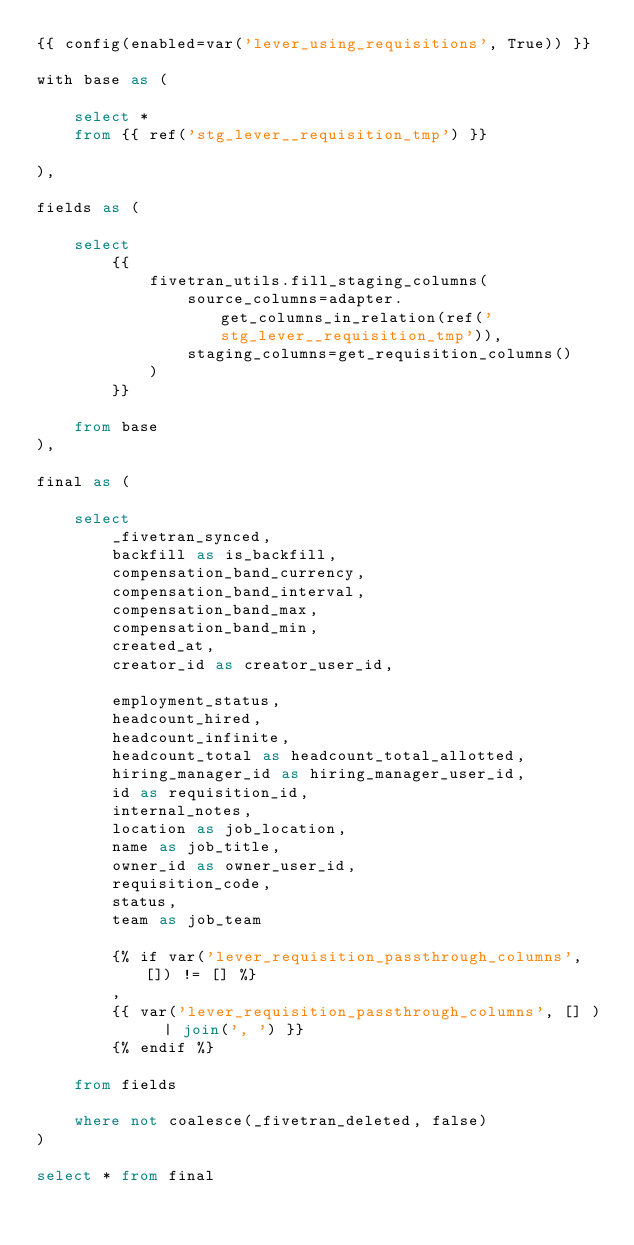<code> <loc_0><loc_0><loc_500><loc_500><_SQL_>{{ config(enabled=var('lever_using_requisitions', True)) }}

with base as (

    select * 
    from {{ ref('stg_lever__requisition_tmp') }}

),

fields as (

    select
        {{
            fivetran_utils.fill_staging_columns(
                source_columns=adapter.get_columns_in_relation(ref('stg_lever__requisition_tmp')),
                staging_columns=get_requisition_columns()
            )
        }}
        
    from base
),

final as (
    
    select 
        _fivetran_synced,
        backfill as is_backfill,
        compensation_band_currency,
        compensation_band_interval,
        compensation_band_max,
        compensation_band_min,
        created_at,
        creator_id as creator_user_id,
        
        employment_status,
        headcount_hired,
        headcount_infinite, 
        headcount_total as headcount_total_allotted,
        hiring_manager_id as hiring_manager_user_id,
        id as requisition_id,
        internal_notes,
        location as job_location,
        name as job_title,
        owner_id as owner_user_id,
        requisition_code,
        status,
        team as job_team

        {% if var('lever_requisition_passthrough_columns', []) != [] %}
        ,
        {{ var('lever_requisition_passthrough_columns', [] )  | join(', ') }}
        {% endif %}
        
    from fields

    where not coalesce(_fivetran_deleted, false)
)

select * from final
</code> 